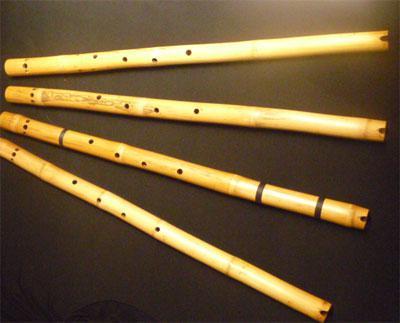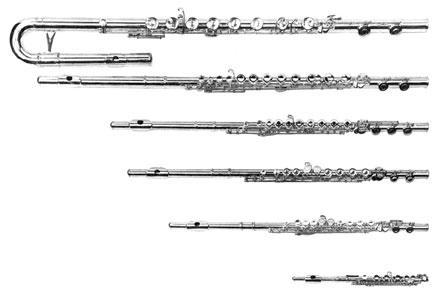The first image is the image on the left, the second image is the image on the right. For the images shown, is this caption "An image contains various flute like instruments with an all white background." true? Answer yes or no. Yes. The first image is the image on the left, the second image is the image on the right. For the images displayed, is the sentence "There are at least  15 flutes that are white, black or brown sitting on  multiple shelves." factually correct? Answer yes or no. No. 